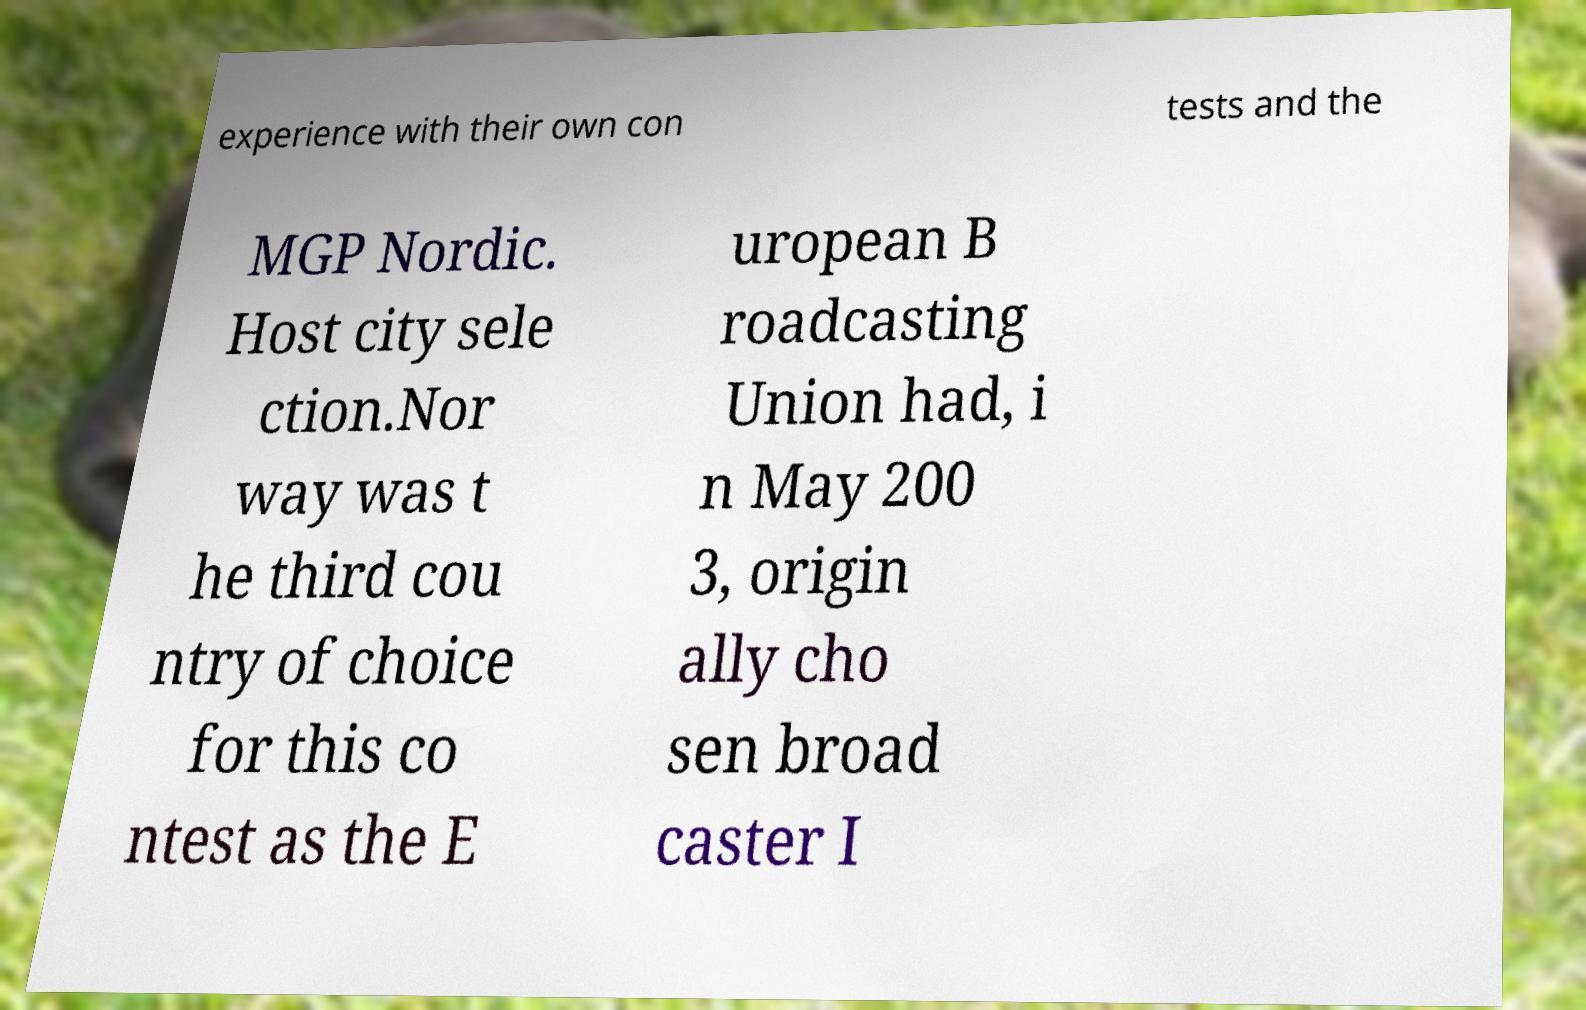I need the written content from this picture converted into text. Can you do that? experience with their own con tests and the MGP Nordic. Host city sele ction.Nor way was t he third cou ntry of choice for this co ntest as the E uropean B roadcasting Union had, i n May 200 3, origin ally cho sen broad caster I 